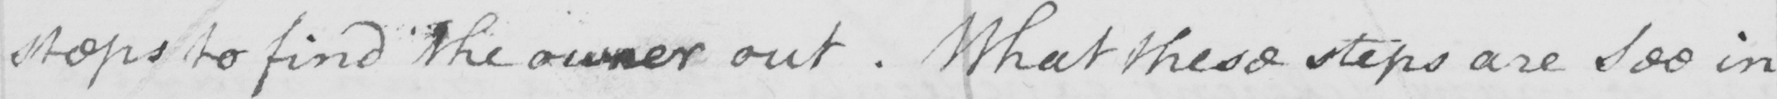What does this handwritten line say? steps to find the owner out . What these steps are see in 